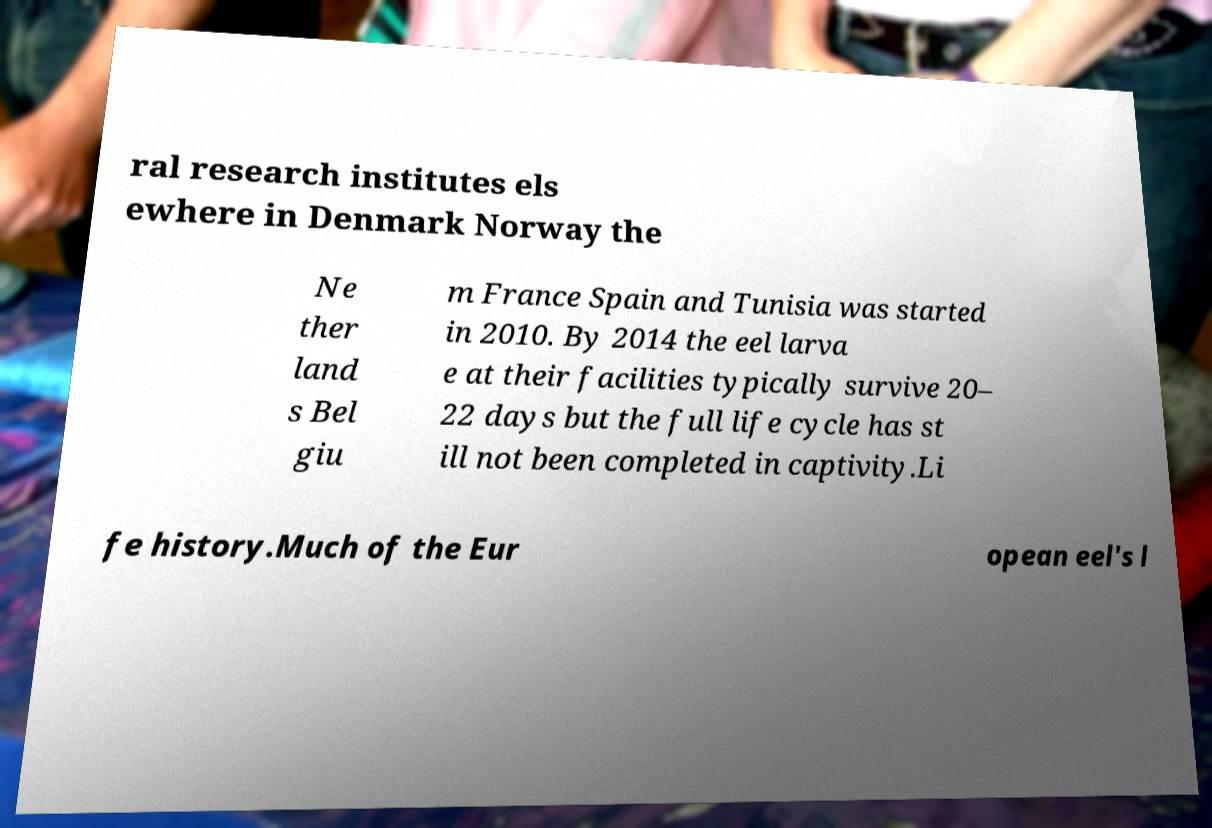What messages or text are displayed in this image? I need them in a readable, typed format. ral research institutes els ewhere in Denmark Norway the Ne ther land s Bel giu m France Spain and Tunisia was started in 2010. By 2014 the eel larva e at their facilities typically survive 20– 22 days but the full life cycle has st ill not been completed in captivity.Li fe history.Much of the Eur opean eel's l 